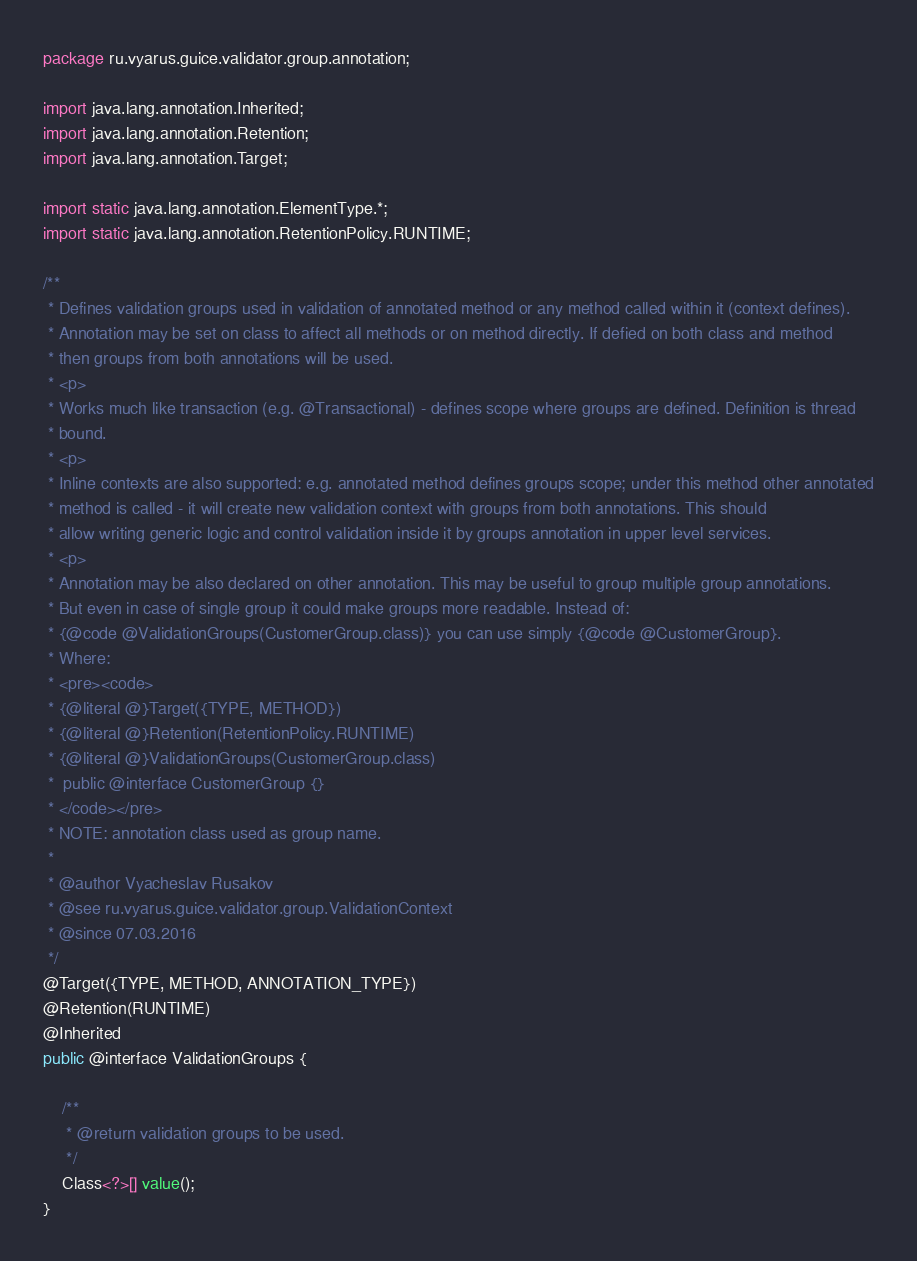<code> <loc_0><loc_0><loc_500><loc_500><_Java_>package ru.vyarus.guice.validator.group.annotation;

import java.lang.annotation.Inherited;
import java.lang.annotation.Retention;
import java.lang.annotation.Target;

import static java.lang.annotation.ElementType.*;
import static java.lang.annotation.RetentionPolicy.RUNTIME;

/**
 * Defines validation groups used in validation of annotated method or any method called within it (context defines).
 * Annotation may be set on class to affect all methods or on method directly. If defied on both class and method
 * then groups from both annotations will be used.
 * <p>
 * Works much like transaction (e.g. @Transactional) - defines scope where groups are defined. Definition is thread
 * bound.
 * <p>
 * Inline contexts are also supported: e.g. annotated method defines groups scope; under this method other annotated
 * method is called - it will create new validation context with groups from both annotations. This should
 * allow writing generic logic and control validation inside it by groups annotation in upper level services.
 * <p>
 * Annotation may be also declared on other annotation. This may be useful to group multiple group annotations.
 * But even in case of single group it could make groups more readable. Instead of:
 * {@code @ValidationGroups(CustomerGroup.class)} you can use simply {@code @CustomerGroup}.
 * Where:
 * <pre><code>
 * {@literal @}Target({TYPE, METHOD})
 * {@literal @}Retention(RetentionPolicy.RUNTIME)
 * {@literal @}ValidationGroups(CustomerGroup.class)
 *  public @interface CustomerGroup {}
 * </code></pre>
 * NOTE: annotation class used as group name.
 *
 * @author Vyacheslav Rusakov
 * @see ru.vyarus.guice.validator.group.ValidationContext
 * @since 07.03.2016
 */
@Target({TYPE, METHOD, ANNOTATION_TYPE})
@Retention(RUNTIME)
@Inherited
public @interface ValidationGroups {

    /**
     * @return validation groups to be used.
     */
    Class<?>[] value();
}
</code> 